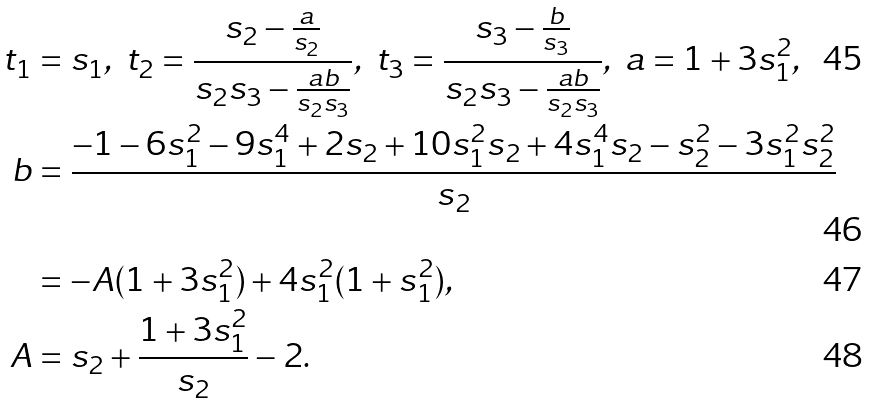<formula> <loc_0><loc_0><loc_500><loc_500>t _ { 1 } & = s _ { 1 } , \ t _ { 2 } = \frac { s _ { 2 } - \frac { a } { s _ { 2 } } } { s _ { 2 } s _ { 3 } - \frac { a b } { s _ { 2 } s _ { 3 } } } , \ t _ { 3 } = \frac { s _ { 3 } - \frac { b } { s _ { 3 } } } { s _ { 2 } s _ { 3 } - \frac { a b } { s _ { 2 } s _ { 3 } } } , \ a = 1 + 3 s _ { 1 } ^ { 2 } , \\ b & = \frac { - 1 - 6 s _ { 1 } ^ { 2 } - 9 s _ { 1 } ^ { 4 } + 2 s _ { 2 } + 1 0 s _ { 1 } ^ { 2 } s _ { 2 } + 4 s _ { 1 } ^ { 4 } s _ { 2 } - s _ { 2 } ^ { 2 } - 3 s _ { 1 } ^ { 2 } s _ { 2 } ^ { 2 } } { s _ { 2 } } \\ & = - A ( 1 + 3 s _ { 1 } ^ { 2 } ) + 4 s _ { 1 } ^ { 2 } ( 1 + s _ { 1 } ^ { 2 } ) , \\ A & = s _ { 2 } + \frac { 1 + 3 s _ { 1 } ^ { 2 } } { s _ { 2 } } - 2 .</formula> 